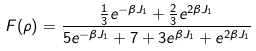Convert formula to latex. <formula><loc_0><loc_0><loc_500><loc_500>F ( \rho ) = \frac { \frac { 1 } { 3 } e ^ { - \beta J _ { 1 } } + \frac { 2 } { 3 } e ^ { 2 \beta J _ { 1 } } } { 5 e ^ { - \beta J _ { 1 } } + 7 + 3 e ^ { \beta J _ { 1 } } + e ^ { 2 \beta J _ { 1 } } }</formula> 